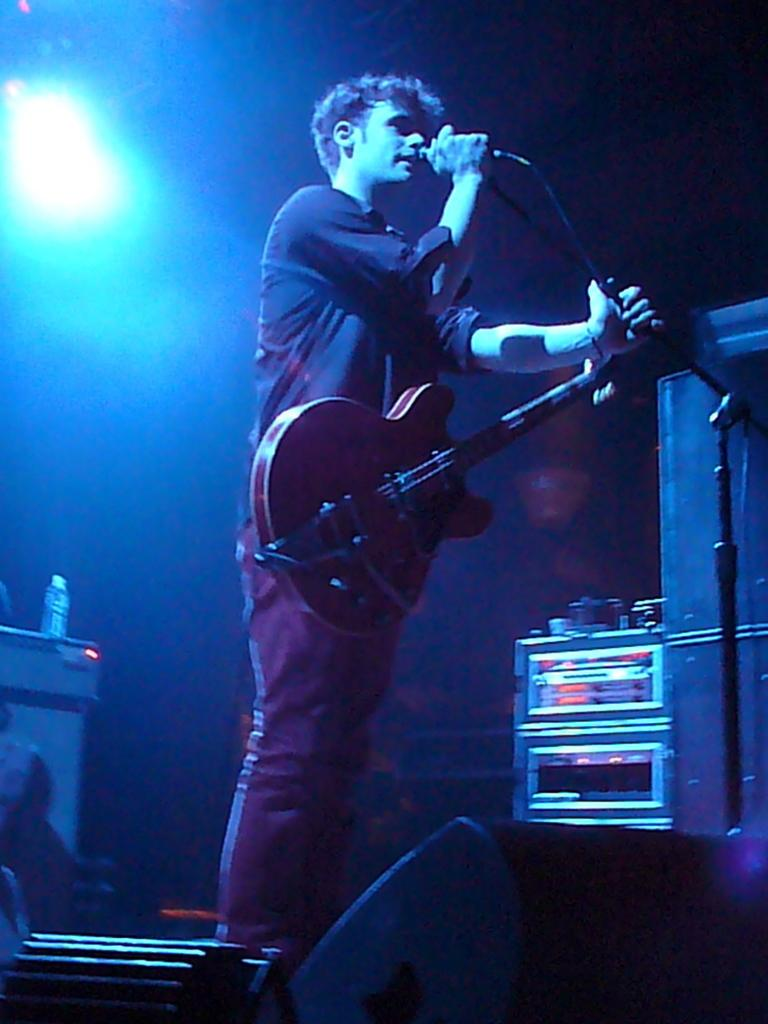What is the person in the image doing? The person is holding a guitar and standing in front of a microphone. What object is the person holding? The person is holding a guitar. What is located behind the person? There is a table in the image. What is on the table? There is a bottle on the table. What can be seen in the image that provides light? There is a light visible in the image. What type of engine is visible in the image? There is no engine present in the image. What emotion does the person in the image appear to be experiencing? The image does not convey any specific emotion, so it cannot be determined from the image alone. 